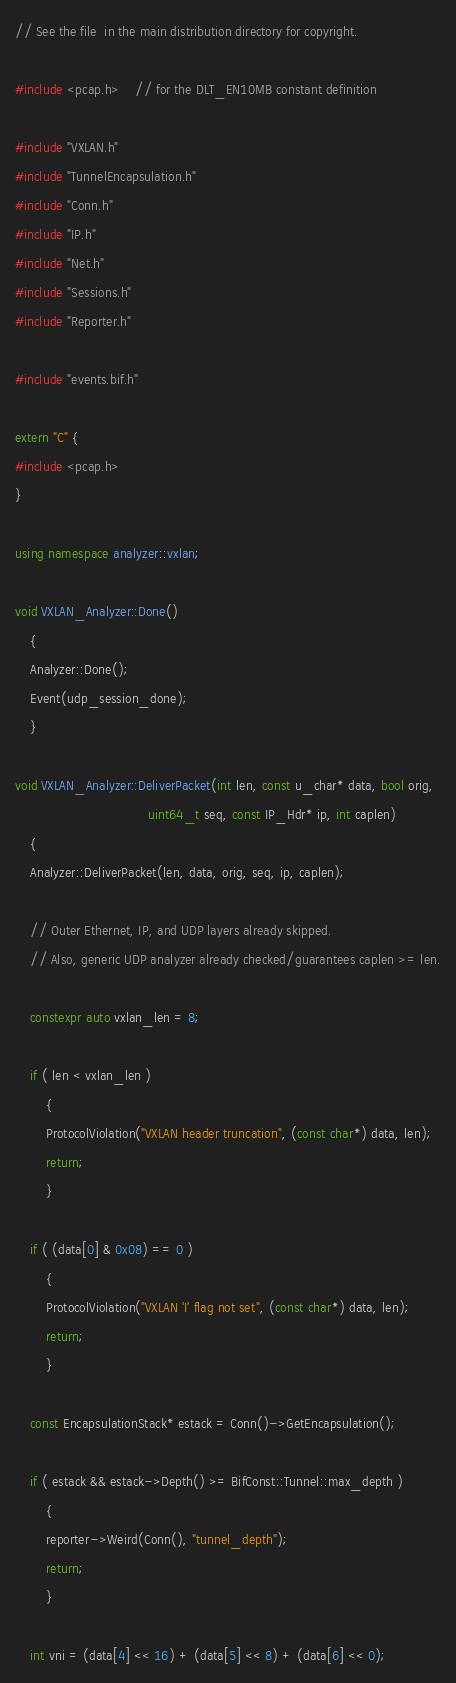Convert code to text. <code><loc_0><loc_0><loc_500><loc_500><_C++_>// See the file  in the main distribution directory for copyright.

#include <pcap.h>	// for the DLT_EN10MB constant definition

#include "VXLAN.h"
#include "TunnelEncapsulation.h"
#include "Conn.h"
#include "IP.h"
#include "Net.h"
#include "Sessions.h"
#include "Reporter.h"

#include "events.bif.h"

extern "C" {
#include <pcap.h>
}

using namespace analyzer::vxlan;

void VXLAN_Analyzer::Done()
	{
	Analyzer::Done();
	Event(udp_session_done);
	}

void VXLAN_Analyzer::DeliverPacket(int len, const u_char* data, bool orig,
                                   uint64_t seq, const IP_Hdr* ip, int caplen)
	{
	Analyzer::DeliverPacket(len, data, orig, seq, ip, caplen);

	// Outer Ethernet, IP, and UDP layers already skipped.
	// Also, generic UDP analyzer already checked/guarantees caplen >= len.

	constexpr auto vxlan_len = 8;

	if ( len < vxlan_len )
		{
		ProtocolViolation("VXLAN header truncation", (const char*) data, len);
		return;
		}

	if ( (data[0] & 0x08) == 0 )
		{
		ProtocolViolation("VXLAN 'I' flag not set", (const char*) data, len);
		return;
		}

	const EncapsulationStack* estack = Conn()->GetEncapsulation();

	if ( estack && estack->Depth() >= BifConst::Tunnel::max_depth )
		{
		reporter->Weird(Conn(), "tunnel_depth");
		return;
		}

	int vni = (data[4] << 16) + (data[5] << 8) + (data[6] << 0);
</code> 